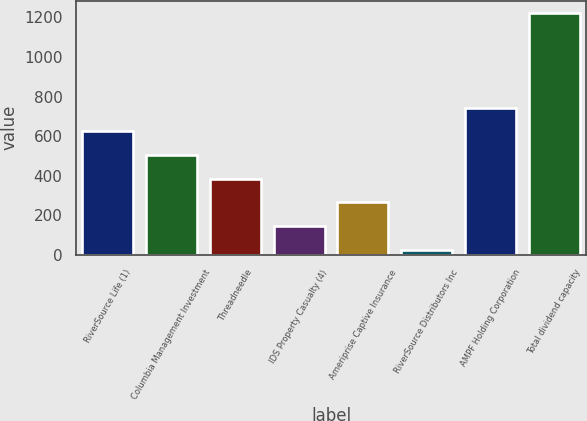<chart> <loc_0><loc_0><loc_500><loc_500><bar_chart><fcel>RiverSource Life (1)<fcel>Columbia Management Investment<fcel>Threadneedle<fcel>IDS Property Casualty (4)<fcel>Ameriprise Captive Insurance<fcel>RiverSource Distributors Inc<fcel>AMPF Holding Corporation<fcel>Total dividend capacity<nl><fcel>625<fcel>505.2<fcel>385.4<fcel>145.8<fcel>265.6<fcel>26<fcel>744.8<fcel>1224<nl></chart> 